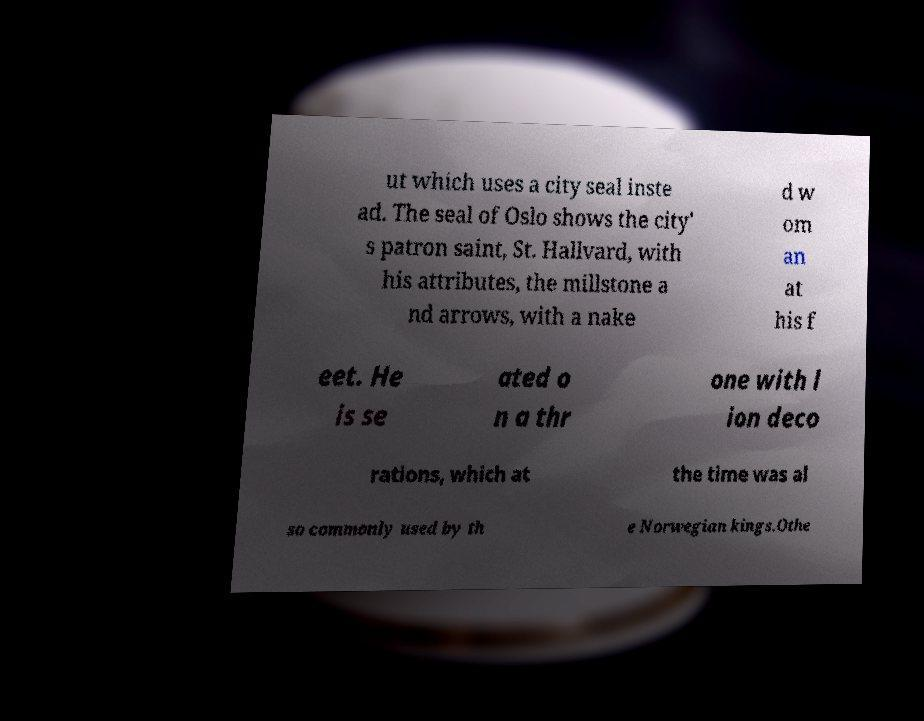Please read and relay the text visible in this image. What does it say? ut which uses a city seal inste ad. The seal of Oslo shows the city' s patron saint, St. Hallvard, with his attributes, the millstone a nd arrows, with a nake d w om an at his f eet. He is se ated o n a thr one with l ion deco rations, which at the time was al so commonly used by th e Norwegian kings.Othe 